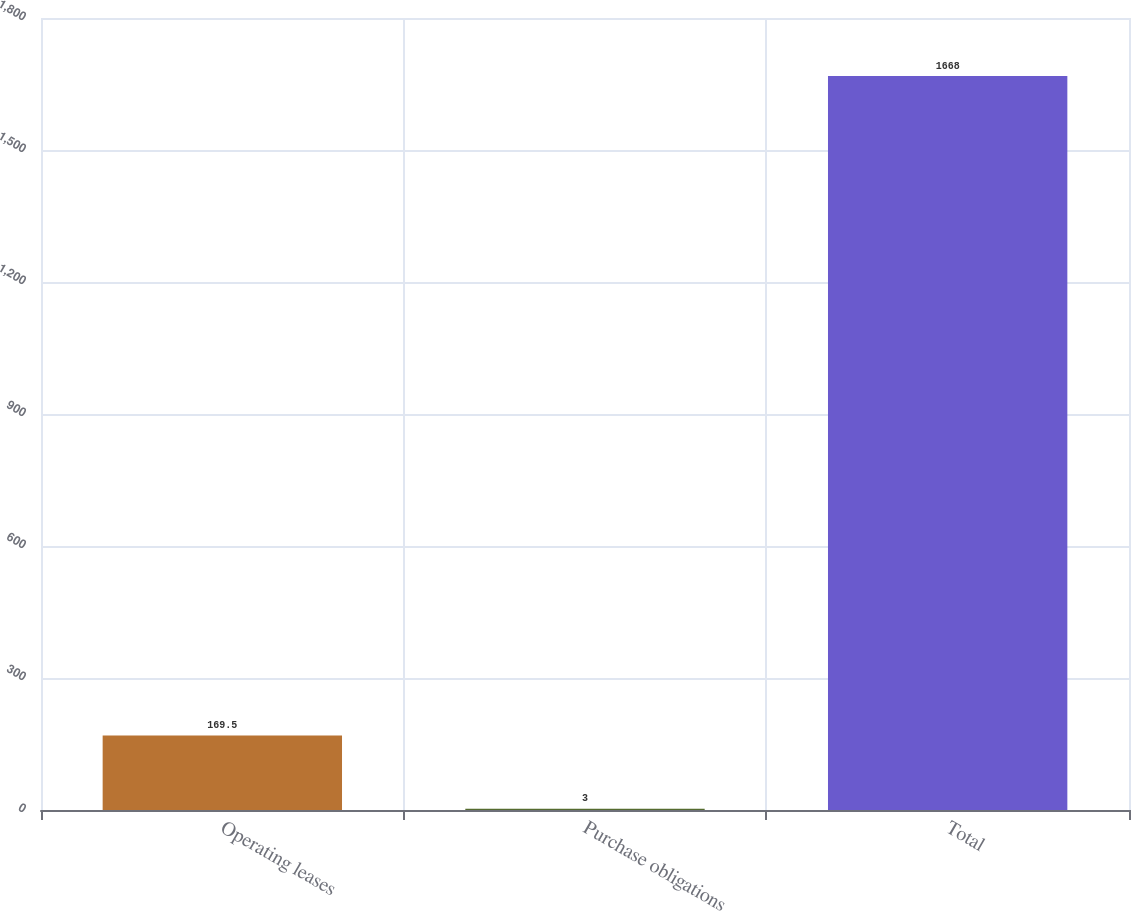Convert chart. <chart><loc_0><loc_0><loc_500><loc_500><bar_chart><fcel>Operating leases<fcel>Purchase obligations<fcel>Total<nl><fcel>169.5<fcel>3<fcel>1668<nl></chart> 